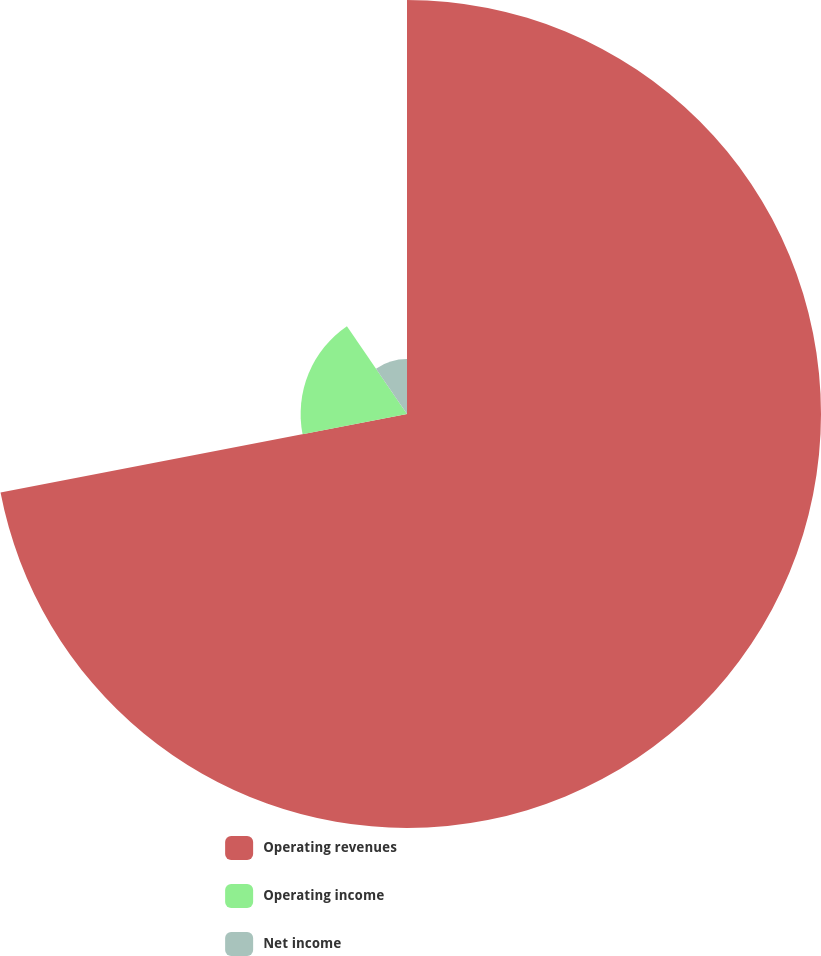<chart> <loc_0><loc_0><loc_500><loc_500><pie_chart><fcel>Operating revenues<fcel>Operating income<fcel>Net income<nl><fcel>71.96%<fcel>18.49%<fcel>9.55%<nl></chart> 